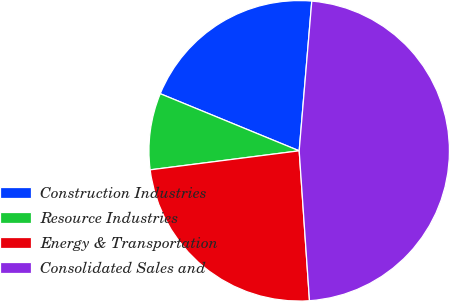Convert chart to OTSL. <chart><loc_0><loc_0><loc_500><loc_500><pie_chart><fcel>Construction Industries<fcel>Resource Industries<fcel>Energy & Transportation<fcel>Consolidated Sales and<nl><fcel>20.13%<fcel>8.23%<fcel>24.07%<fcel>47.57%<nl></chart> 